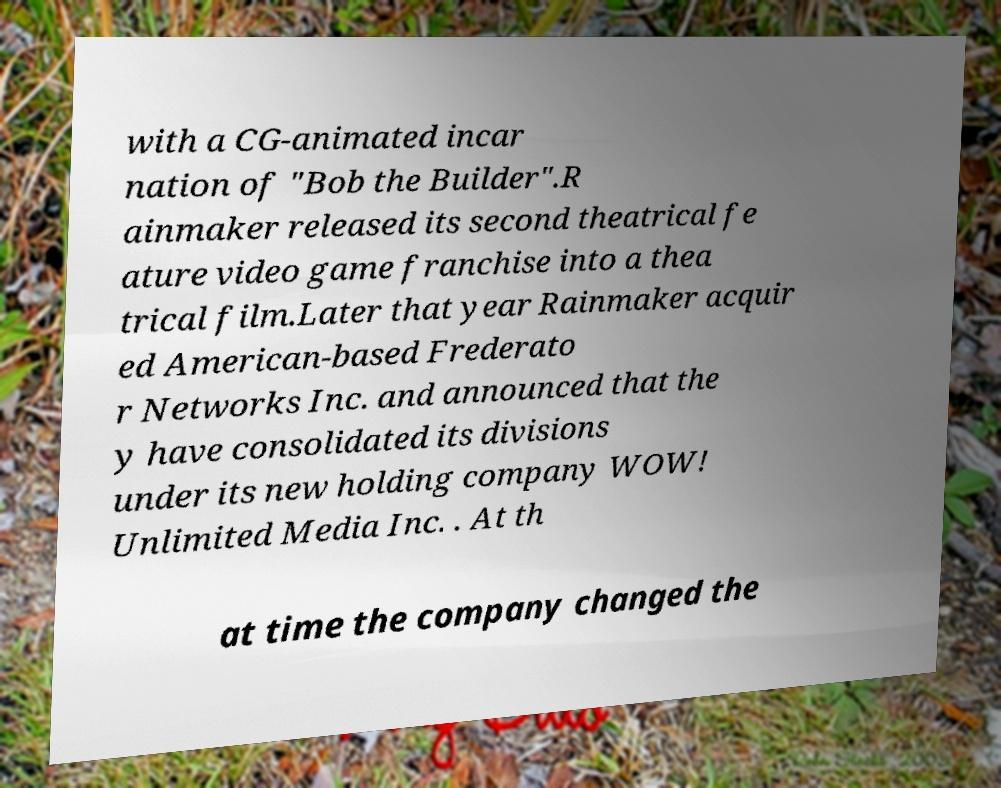Could you extract and type out the text from this image? with a CG-animated incar nation of "Bob the Builder".R ainmaker released its second theatrical fe ature video game franchise into a thea trical film.Later that year Rainmaker acquir ed American-based Frederato r Networks Inc. and announced that the y have consolidated its divisions under its new holding company WOW! Unlimited Media Inc. . At th at time the company changed the 